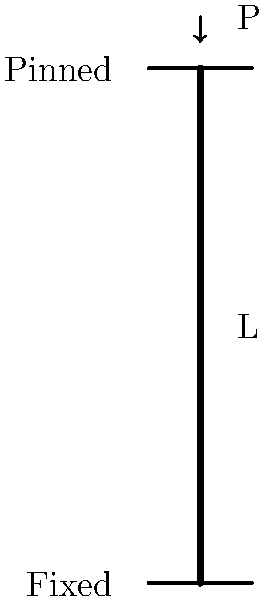As a reliable coworker who often covers shifts during busy travel periods, you're asked to determine the critical buckling load for a column in a temporary structure. The column has a fixed base and a pinned top, as shown in the figure. Given that the column has a length $L$, modulus of elasticity $E$, and moment of inertia $I$, what is the expression for the critical buckling load $P_{cr}$? To determine the critical buckling load for a column with different end conditions, we follow these steps:

1. Identify the end conditions: In this case, we have a fixed base and a pinned top.

2. Determine the effective length factor (K):
   For a fixed-pinned column, K = 0.699

3. Recall Euler's critical buckling load formula:
   $$P_{cr} = \frac{\pi^2 EI}{(KL)^2}$$

4. Substitute the effective length factor:
   $$P_{cr} = \frac{\pi^2 EI}{(0.699L)^2}$$

5. Simplify the expression:
   $$P_{cr} = \frac{\pi^2 EI}{0.488601L^2}$$

6. Further simplification:
   $$P_{cr} = \frac{20.19 EI}{L^2}$$

This final expression represents the critical buckling load for the given column with a fixed base and a pinned top.
Answer: $$P_{cr} = \frac{20.19 EI}{L^2}$$ 